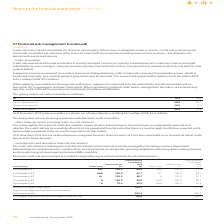According to Intu Properties's financial document, What is the percentage of assets at risk in 2019? According to the financial document, 95%. The relevant text states: "argest exposures as a percentage of assets at risk 95% 89%..." Also, What is the sum of cash deposits and derivative financial instrument assets in 2018? According to the financial document, 244.2 (in millions). The relevant text states: "and derivative financial instrument assets 203.5 244.2..." Also, Which model did the Group apply to assess credit risk of financial assets? expected credit loss model. The document states: "ing loans to joint ventures The Group applies the expected credit loss model in respect of other financial assets. Financial assets are individually a..." Also, How many counterparties have authorised limit above 125.0 million in 2019? Based on the analysis, there are 1 instances. The counting process: Counterparty #2. Also, can you calculate: What is the percentage of counterparty #5 exposure in the total exposure in 2019? Based on the calculation: 20.0/192.7, the result is 10.38 (percentage). This is based on the information: "Sum of five largest exposures 192.7 217.8 Counterparty #5 A 75.0 20.0 AAA 150.0 12.3..." The key data points involved are: 192.7, 20.0. Also, can you calculate: What is the percentage change in the sum of cash deposits and derivative financial instrument assets from 2018 to 2019? To answer this question, I need to perform calculations using the financial data. The calculation is: (203.5-244.2)/244.2, which equals -16.67 (percentage). This is based on the information: "and derivative financial instrument assets 203.5 244.2 posits and derivative financial instrument assets 203.5 244.2..." The key data points involved are: 203.5, 244.2. 